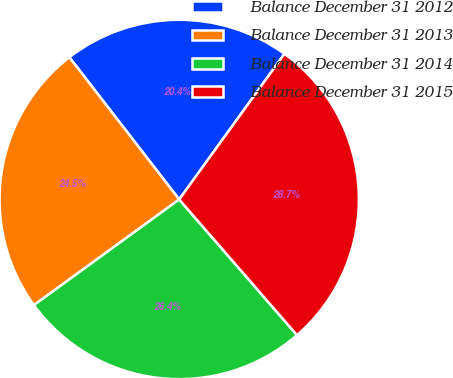<chart> <loc_0><loc_0><loc_500><loc_500><pie_chart><fcel>Balance December 31 2012<fcel>Balance December 31 2013<fcel>Balance December 31 2014<fcel>Balance December 31 2015<nl><fcel>20.43%<fcel>24.54%<fcel>26.37%<fcel>28.66%<nl></chart> 